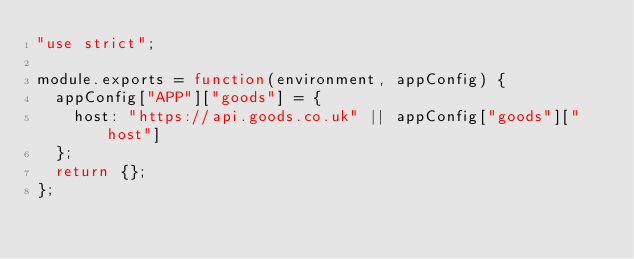<code> <loc_0><loc_0><loc_500><loc_500><_JavaScript_>"use strict";

module.exports = function(environment, appConfig) {
  appConfig["APP"]["goods"] = {
    host: "https://api.goods.co.uk" || appConfig["goods"]["host"]
  };
  return {};
};
</code> 